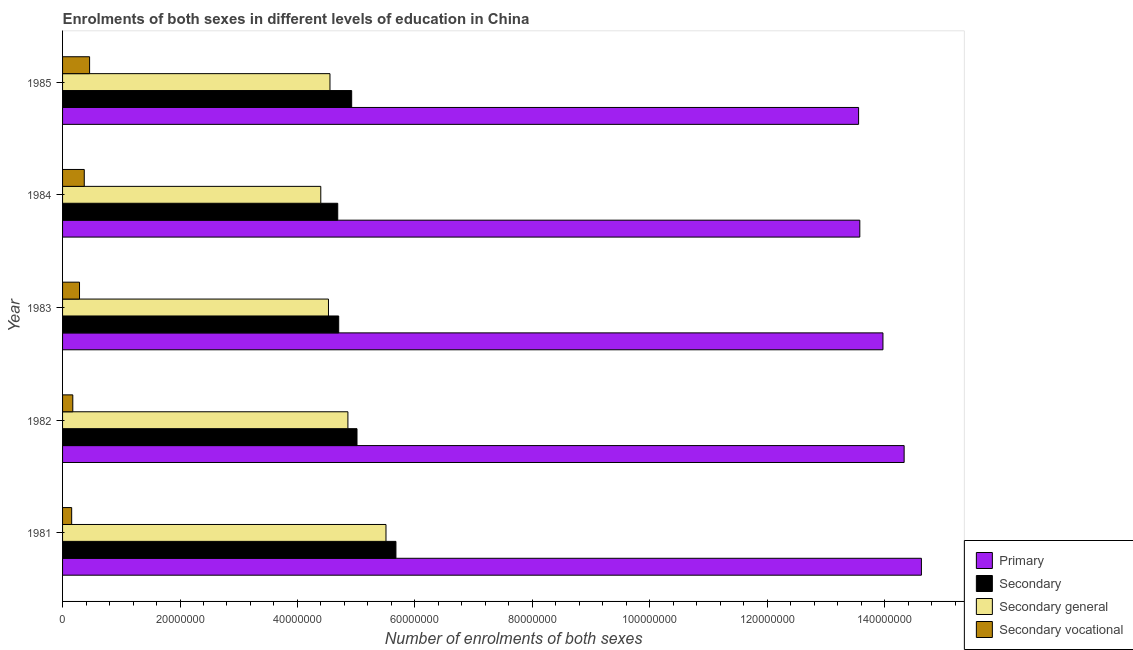Are the number of bars on each tick of the Y-axis equal?
Offer a very short reply. Yes. How many bars are there on the 1st tick from the top?
Your answer should be very brief. 4. How many bars are there on the 5th tick from the bottom?
Your response must be concise. 4. What is the label of the 3rd group of bars from the top?
Your answer should be very brief. 1983. In how many cases, is the number of bars for a given year not equal to the number of legend labels?
Make the answer very short. 0. What is the number of enrolments in secondary vocational education in 1984?
Provide a short and direct response. 3.70e+06. Across all years, what is the maximum number of enrolments in primary education?
Make the answer very short. 1.46e+08. Across all years, what is the minimum number of enrolments in secondary general education?
Make the answer very short. 4.40e+07. What is the total number of enrolments in secondary vocational education in the graph?
Your answer should be compact. 1.45e+07. What is the difference between the number of enrolments in primary education in 1981 and that in 1984?
Offer a very short reply. 1.05e+07. What is the difference between the number of enrolments in secondary general education in 1982 and the number of enrolments in secondary education in 1983?
Offer a terse response. 1.57e+06. What is the average number of enrolments in primary education per year?
Your response must be concise. 1.40e+08. In the year 1981, what is the difference between the number of enrolments in primary education and number of enrolments in secondary education?
Ensure brevity in your answer.  8.95e+07. What is the ratio of the number of enrolments in primary education in 1982 to that in 1985?
Offer a terse response. 1.06. Is the number of enrolments in primary education in 1981 less than that in 1985?
Ensure brevity in your answer.  No. What is the difference between the highest and the second highest number of enrolments in secondary education?
Keep it short and to the point. 6.63e+06. What is the difference between the highest and the lowest number of enrolments in primary education?
Your answer should be compact. 1.07e+07. Is the sum of the number of enrolments in secondary vocational education in 1982 and 1985 greater than the maximum number of enrolments in secondary education across all years?
Your answer should be compact. No. What does the 1st bar from the top in 1981 represents?
Offer a very short reply. Secondary vocational. What does the 3rd bar from the bottom in 1981 represents?
Provide a succinct answer. Secondary general. Is it the case that in every year, the sum of the number of enrolments in primary education and number of enrolments in secondary education is greater than the number of enrolments in secondary general education?
Provide a short and direct response. Yes. How many bars are there?
Give a very brief answer. 20. Are all the bars in the graph horizontal?
Provide a succinct answer. Yes. How many years are there in the graph?
Make the answer very short. 5. What is the difference between two consecutive major ticks on the X-axis?
Your response must be concise. 2.00e+07. Where does the legend appear in the graph?
Give a very brief answer. Bottom right. How many legend labels are there?
Your answer should be compact. 4. What is the title of the graph?
Your response must be concise. Enrolments of both sexes in different levels of education in China. Does "Mammal species" appear as one of the legend labels in the graph?
Your answer should be compact. No. What is the label or title of the X-axis?
Your response must be concise. Number of enrolments of both sexes. What is the Number of enrolments of both sexes of Primary in 1981?
Provide a short and direct response. 1.46e+08. What is the Number of enrolments of both sexes in Secondary in 1981?
Your answer should be very brief. 5.68e+07. What is the Number of enrolments of both sexes in Secondary general in 1981?
Make the answer very short. 5.51e+07. What is the Number of enrolments of both sexes in Secondary vocational in 1981?
Ensure brevity in your answer.  1.55e+06. What is the Number of enrolments of both sexes in Primary in 1982?
Provide a short and direct response. 1.43e+08. What is the Number of enrolments of both sexes in Secondary in 1982?
Offer a very short reply. 5.01e+07. What is the Number of enrolments of both sexes in Secondary general in 1982?
Provide a succinct answer. 4.86e+07. What is the Number of enrolments of both sexes of Secondary vocational in 1982?
Provide a succinct answer. 1.74e+06. What is the Number of enrolments of both sexes of Primary in 1983?
Offer a very short reply. 1.40e+08. What is the Number of enrolments of both sexes of Secondary in 1983?
Offer a very short reply. 4.70e+07. What is the Number of enrolments of both sexes in Secondary general in 1983?
Offer a terse response. 4.53e+07. What is the Number of enrolments of both sexes of Secondary vocational in 1983?
Make the answer very short. 2.89e+06. What is the Number of enrolments of both sexes in Primary in 1984?
Provide a succinct answer. 1.36e+08. What is the Number of enrolments of both sexes of Secondary in 1984?
Provide a short and direct response. 4.69e+07. What is the Number of enrolments of both sexes in Secondary general in 1984?
Give a very brief answer. 4.40e+07. What is the Number of enrolments of both sexes of Secondary vocational in 1984?
Keep it short and to the point. 3.70e+06. What is the Number of enrolments of both sexes in Primary in 1985?
Give a very brief answer. 1.36e+08. What is the Number of enrolments of both sexes of Secondary in 1985?
Ensure brevity in your answer.  4.92e+07. What is the Number of enrolments of both sexes of Secondary general in 1985?
Keep it short and to the point. 4.55e+07. What is the Number of enrolments of both sexes in Secondary vocational in 1985?
Your response must be concise. 4.60e+06. Across all years, what is the maximum Number of enrolments of both sexes in Primary?
Ensure brevity in your answer.  1.46e+08. Across all years, what is the maximum Number of enrolments of both sexes of Secondary?
Offer a terse response. 5.68e+07. Across all years, what is the maximum Number of enrolments of both sexes in Secondary general?
Your answer should be compact. 5.51e+07. Across all years, what is the maximum Number of enrolments of both sexes of Secondary vocational?
Ensure brevity in your answer.  4.60e+06. Across all years, what is the minimum Number of enrolments of both sexes in Primary?
Your answer should be very brief. 1.36e+08. Across all years, what is the minimum Number of enrolments of both sexes of Secondary?
Offer a very short reply. 4.69e+07. Across all years, what is the minimum Number of enrolments of both sexes in Secondary general?
Make the answer very short. 4.40e+07. Across all years, what is the minimum Number of enrolments of both sexes of Secondary vocational?
Provide a short and direct response. 1.55e+06. What is the total Number of enrolments of both sexes in Primary in the graph?
Make the answer very short. 7.01e+08. What is the total Number of enrolments of both sexes in Secondary in the graph?
Offer a very short reply. 2.50e+08. What is the total Number of enrolments of both sexes in Secondary general in the graph?
Make the answer very short. 2.38e+08. What is the total Number of enrolments of both sexes of Secondary vocational in the graph?
Make the answer very short. 1.45e+07. What is the difference between the Number of enrolments of both sexes of Primary in 1981 and that in 1982?
Provide a succinct answer. 2.94e+06. What is the difference between the Number of enrolments of both sexes of Secondary in 1981 and that in 1982?
Keep it short and to the point. 6.63e+06. What is the difference between the Number of enrolments of both sexes in Secondary general in 1981 and that in 1982?
Make the answer very short. 6.48e+06. What is the difference between the Number of enrolments of both sexes of Secondary vocational in 1981 and that in 1982?
Provide a succinct answer. -1.93e+05. What is the difference between the Number of enrolments of both sexes of Primary in 1981 and that in 1983?
Offer a terse response. 6.55e+06. What is the difference between the Number of enrolments of both sexes in Secondary in 1981 and that in 1983?
Offer a very short reply. 9.75e+06. What is the difference between the Number of enrolments of both sexes in Secondary general in 1981 and that in 1983?
Your response must be concise. 9.80e+06. What is the difference between the Number of enrolments of both sexes of Secondary vocational in 1981 and that in 1983?
Your answer should be very brief. -1.34e+06. What is the difference between the Number of enrolments of both sexes of Primary in 1981 and that in 1984?
Offer a terse response. 1.05e+07. What is the difference between the Number of enrolments of both sexes in Secondary in 1981 and that in 1984?
Give a very brief answer. 9.91e+06. What is the difference between the Number of enrolments of both sexes of Secondary general in 1981 and that in 1984?
Your answer should be compact. 1.11e+07. What is the difference between the Number of enrolments of both sexes in Secondary vocational in 1981 and that in 1984?
Your response must be concise. -2.15e+06. What is the difference between the Number of enrolments of both sexes of Primary in 1981 and that in 1985?
Give a very brief answer. 1.07e+07. What is the difference between the Number of enrolments of both sexes of Secondary in 1981 and that in 1985?
Give a very brief answer. 7.54e+06. What is the difference between the Number of enrolments of both sexes of Secondary general in 1981 and that in 1985?
Offer a very short reply. 9.54e+06. What is the difference between the Number of enrolments of both sexes of Secondary vocational in 1981 and that in 1985?
Provide a succinct answer. -3.05e+06. What is the difference between the Number of enrolments of both sexes of Primary in 1982 and that in 1983?
Give a very brief answer. 3.61e+06. What is the difference between the Number of enrolments of both sexes of Secondary in 1982 and that in 1983?
Make the answer very short. 3.12e+06. What is the difference between the Number of enrolments of both sexes of Secondary general in 1982 and that in 1983?
Give a very brief answer. 3.31e+06. What is the difference between the Number of enrolments of both sexes in Secondary vocational in 1982 and that in 1983?
Provide a short and direct response. -1.14e+06. What is the difference between the Number of enrolments of both sexes in Primary in 1982 and that in 1984?
Your answer should be very brief. 7.55e+06. What is the difference between the Number of enrolments of both sexes of Secondary in 1982 and that in 1984?
Give a very brief answer. 3.28e+06. What is the difference between the Number of enrolments of both sexes of Secondary general in 1982 and that in 1984?
Make the answer very short. 4.62e+06. What is the difference between the Number of enrolments of both sexes in Secondary vocational in 1982 and that in 1984?
Keep it short and to the point. -1.95e+06. What is the difference between the Number of enrolments of both sexes in Primary in 1982 and that in 1985?
Offer a very short reply. 7.76e+06. What is the difference between the Number of enrolments of both sexes of Secondary in 1982 and that in 1985?
Make the answer very short. 9.09e+05. What is the difference between the Number of enrolments of both sexes in Secondary general in 1982 and that in 1985?
Offer a very short reply. 3.05e+06. What is the difference between the Number of enrolments of both sexes in Secondary vocational in 1982 and that in 1985?
Offer a terse response. -2.86e+06. What is the difference between the Number of enrolments of both sexes of Primary in 1983 and that in 1984?
Offer a very short reply. 3.94e+06. What is the difference between the Number of enrolments of both sexes in Secondary in 1983 and that in 1984?
Ensure brevity in your answer.  1.63e+05. What is the difference between the Number of enrolments of both sexes in Secondary general in 1983 and that in 1984?
Your response must be concise. 1.31e+06. What is the difference between the Number of enrolments of both sexes in Secondary vocational in 1983 and that in 1984?
Offer a very short reply. -8.08e+05. What is the difference between the Number of enrolments of both sexes of Primary in 1983 and that in 1985?
Your response must be concise. 4.15e+06. What is the difference between the Number of enrolments of both sexes of Secondary in 1983 and that in 1985?
Keep it short and to the point. -2.21e+06. What is the difference between the Number of enrolments of both sexes in Secondary general in 1983 and that in 1985?
Make the answer very short. -2.56e+05. What is the difference between the Number of enrolments of both sexes in Secondary vocational in 1983 and that in 1985?
Make the answer very short. -1.72e+06. What is the difference between the Number of enrolments of both sexes in Primary in 1984 and that in 1985?
Provide a short and direct response. 2.09e+05. What is the difference between the Number of enrolments of both sexes in Secondary in 1984 and that in 1985?
Keep it short and to the point. -2.37e+06. What is the difference between the Number of enrolments of both sexes of Secondary general in 1984 and that in 1985?
Offer a terse response. -1.56e+06. What is the difference between the Number of enrolments of both sexes in Secondary vocational in 1984 and that in 1985?
Provide a succinct answer. -9.09e+05. What is the difference between the Number of enrolments of both sexes in Primary in 1981 and the Number of enrolments of both sexes in Secondary in 1982?
Offer a very short reply. 9.61e+07. What is the difference between the Number of enrolments of both sexes in Primary in 1981 and the Number of enrolments of both sexes in Secondary general in 1982?
Your answer should be very brief. 9.77e+07. What is the difference between the Number of enrolments of both sexes in Primary in 1981 and the Number of enrolments of both sexes in Secondary vocational in 1982?
Your answer should be very brief. 1.45e+08. What is the difference between the Number of enrolments of both sexes of Secondary in 1981 and the Number of enrolments of both sexes of Secondary general in 1982?
Give a very brief answer. 8.18e+06. What is the difference between the Number of enrolments of both sexes of Secondary in 1981 and the Number of enrolments of both sexes of Secondary vocational in 1982?
Keep it short and to the point. 5.50e+07. What is the difference between the Number of enrolments of both sexes in Secondary general in 1981 and the Number of enrolments of both sexes in Secondary vocational in 1982?
Your answer should be compact. 5.33e+07. What is the difference between the Number of enrolments of both sexes of Primary in 1981 and the Number of enrolments of both sexes of Secondary in 1983?
Offer a very short reply. 9.92e+07. What is the difference between the Number of enrolments of both sexes of Primary in 1981 and the Number of enrolments of both sexes of Secondary general in 1983?
Your answer should be very brief. 1.01e+08. What is the difference between the Number of enrolments of both sexes in Primary in 1981 and the Number of enrolments of both sexes in Secondary vocational in 1983?
Make the answer very short. 1.43e+08. What is the difference between the Number of enrolments of both sexes of Secondary in 1981 and the Number of enrolments of both sexes of Secondary general in 1983?
Provide a short and direct response. 1.15e+07. What is the difference between the Number of enrolments of both sexes of Secondary in 1981 and the Number of enrolments of both sexes of Secondary vocational in 1983?
Make the answer very short. 5.39e+07. What is the difference between the Number of enrolments of both sexes in Secondary general in 1981 and the Number of enrolments of both sexes in Secondary vocational in 1983?
Your answer should be compact. 5.22e+07. What is the difference between the Number of enrolments of both sexes in Primary in 1981 and the Number of enrolments of both sexes in Secondary in 1984?
Provide a succinct answer. 9.94e+07. What is the difference between the Number of enrolments of both sexes in Primary in 1981 and the Number of enrolments of both sexes in Secondary general in 1984?
Ensure brevity in your answer.  1.02e+08. What is the difference between the Number of enrolments of both sexes of Primary in 1981 and the Number of enrolments of both sexes of Secondary vocational in 1984?
Your answer should be compact. 1.43e+08. What is the difference between the Number of enrolments of both sexes in Secondary in 1981 and the Number of enrolments of both sexes in Secondary general in 1984?
Your answer should be compact. 1.28e+07. What is the difference between the Number of enrolments of both sexes of Secondary in 1981 and the Number of enrolments of both sexes of Secondary vocational in 1984?
Keep it short and to the point. 5.31e+07. What is the difference between the Number of enrolments of both sexes in Secondary general in 1981 and the Number of enrolments of both sexes in Secondary vocational in 1984?
Offer a very short reply. 5.14e+07. What is the difference between the Number of enrolments of both sexes in Primary in 1981 and the Number of enrolments of both sexes in Secondary in 1985?
Offer a very short reply. 9.70e+07. What is the difference between the Number of enrolments of both sexes of Primary in 1981 and the Number of enrolments of both sexes of Secondary general in 1985?
Keep it short and to the point. 1.01e+08. What is the difference between the Number of enrolments of both sexes of Primary in 1981 and the Number of enrolments of both sexes of Secondary vocational in 1985?
Keep it short and to the point. 1.42e+08. What is the difference between the Number of enrolments of both sexes of Secondary in 1981 and the Number of enrolments of both sexes of Secondary general in 1985?
Keep it short and to the point. 1.12e+07. What is the difference between the Number of enrolments of both sexes in Secondary in 1981 and the Number of enrolments of both sexes in Secondary vocational in 1985?
Provide a short and direct response. 5.22e+07. What is the difference between the Number of enrolments of both sexes of Secondary general in 1981 and the Number of enrolments of both sexes of Secondary vocational in 1985?
Offer a terse response. 5.05e+07. What is the difference between the Number of enrolments of both sexes of Primary in 1982 and the Number of enrolments of both sexes of Secondary in 1983?
Provide a succinct answer. 9.63e+07. What is the difference between the Number of enrolments of both sexes in Primary in 1982 and the Number of enrolments of both sexes in Secondary general in 1983?
Your response must be concise. 9.80e+07. What is the difference between the Number of enrolments of both sexes in Primary in 1982 and the Number of enrolments of both sexes in Secondary vocational in 1983?
Make the answer very short. 1.40e+08. What is the difference between the Number of enrolments of both sexes of Secondary in 1982 and the Number of enrolments of both sexes of Secondary general in 1983?
Offer a terse response. 4.86e+06. What is the difference between the Number of enrolments of both sexes of Secondary in 1982 and the Number of enrolments of both sexes of Secondary vocational in 1983?
Your response must be concise. 4.73e+07. What is the difference between the Number of enrolments of both sexes of Secondary general in 1982 and the Number of enrolments of both sexes of Secondary vocational in 1983?
Offer a terse response. 4.57e+07. What is the difference between the Number of enrolments of both sexes in Primary in 1982 and the Number of enrolments of both sexes in Secondary in 1984?
Provide a short and direct response. 9.65e+07. What is the difference between the Number of enrolments of both sexes of Primary in 1982 and the Number of enrolments of both sexes of Secondary general in 1984?
Give a very brief answer. 9.94e+07. What is the difference between the Number of enrolments of both sexes of Primary in 1982 and the Number of enrolments of both sexes of Secondary vocational in 1984?
Keep it short and to the point. 1.40e+08. What is the difference between the Number of enrolments of both sexes of Secondary in 1982 and the Number of enrolments of both sexes of Secondary general in 1984?
Offer a terse response. 6.17e+06. What is the difference between the Number of enrolments of both sexes in Secondary in 1982 and the Number of enrolments of both sexes in Secondary vocational in 1984?
Offer a very short reply. 4.65e+07. What is the difference between the Number of enrolments of both sexes of Secondary general in 1982 and the Number of enrolments of both sexes of Secondary vocational in 1984?
Your response must be concise. 4.49e+07. What is the difference between the Number of enrolments of both sexes of Primary in 1982 and the Number of enrolments of both sexes of Secondary in 1985?
Your answer should be compact. 9.41e+07. What is the difference between the Number of enrolments of both sexes in Primary in 1982 and the Number of enrolments of both sexes in Secondary general in 1985?
Your answer should be very brief. 9.78e+07. What is the difference between the Number of enrolments of both sexes of Primary in 1982 and the Number of enrolments of both sexes of Secondary vocational in 1985?
Your answer should be very brief. 1.39e+08. What is the difference between the Number of enrolments of both sexes in Secondary in 1982 and the Number of enrolments of both sexes in Secondary general in 1985?
Your response must be concise. 4.60e+06. What is the difference between the Number of enrolments of both sexes in Secondary in 1982 and the Number of enrolments of both sexes in Secondary vocational in 1985?
Give a very brief answer. 4.55e+07. What is the difference between the Number of enrolments of both sexes in Secondary general in 1982 and the Number of enrolments of both sexes in Secondary vocational in 1985?
Make the answer very short. 4.40e+07. What is the difference between the Number of enrolments of both sexes of Primary in 1983 and the Number of enrolments of both sexes of Secondary in 1984?
Your response must be concise. 9.29e+07. What is the difference between the Number of enrolments of both sexes in Primary in 1983 and the Number of enrolments of both sexes in Secondary general in 1984?
Ensure brevity in your answer.  9.57e+07. What is the difference between the Number of enrolments of both sexes in Primary in 1983 and the Number of enrolments of both sexes in Secondary vocational in 1984?
Your answer should be very brief. 1.36e+08. What is the difference between the Number of enrolments of both sexes in Secondary in 1983 and the Number of enrolments of both sexes in Secondary general in 1984?
Offer a very short reply. 3.05e+06. What is the difference between the Number of enrolments of both sexes of Secondary in 1983 and the Number of enrolments of both sexes of Secondary vocational in 1984?
Offer a very short reply. 4.33e+07. What is the difference between the Number of enrolments of both sexes in Secondary general in 1983 and the Number of enrolments of both sexes in Secondary vocational in 1984?
Provide a succinct answer. 4.16e+07. What is the difference between the Number of enrolments of both sexes of Primary in 1983 and the Number of enrolments of both sexes of Secondary in 1985?
Ensure brevity in your answer.  9.05e+07. What is the difference between the Number of enrolments of both sexes in Primary in 1983 and the Number of enrolments of both sexes in Secondary general in 1985?
Offer a terse response. 9.42e+07. What is the difference between the Number of enrolments of both sexes in Primary in 1983 and the Number of enrolments of both sexes in Secondary vocational in 1985?
Provide a short and direct response. 1.35e+08. What is the difference between the Number of enrolments of both sexes of Secondary in 1983 and the Number of enrolments of both sexes of Secondary general in 1985?
Your response must be concise. 1.49e+06. What is the difference between the Number of enrolments of both sexes of Secondary in 1983 and the Number of enrolments of both sexes of Secondary vocational in 1985?
Provide a succinct answer. 4.24e+07. What is the difference between the Number of enrolments of both sexes in Secondary general in 1983 and the Number of enrolments of both sexes in Secondary vocational in 1985?
Keep it short and to the point. 4.07e+07. What is the difference between the Number of enrolments of both sexes in Primary in 1984 and the Number of enrolments of both sexes in Secondary in 1985?
Provide a succinct answer. 8.65e+07. What is the difference between the Number of enrolments of both sexes in Primary in 1984 and the Number of enrolments of both sexes in Secondary general in 1985?
Make the answer very short. 9.02e+07. What is the difference between the Number of enrolments of both sexes of Primary in 1984 and the Number of enrolments of both sexes of Secondary vocational in 1985?
Your answer should be very brief. 1.31e+08. What is the difference between the Number of enrolments of both sexes in Secondary in 1984 and the Number of enrolments of both sexes in Secondary general in 1985?
Ensure brevity in your answer.  1.32e+06. What is the difference between the Number of enrolments of both sexes in Secondary in 1984 and the Number of enrolments of both sexes in Secondary vocational in 1985?
Provide a succinct answer. 4.23e+07. What is the difference between the Number of enrolments of both sexes in Secondary general in 1984 and the Number of enrolments of both sexes in Secondary vocational in 1985?
Offer a very short reply. 3.94e+07. What is the average Number of enrolments of both sexes in Primary per year?
Offer a terse response. 1.40e+08. What is the average Number of enrolments of both sexes in Secondary per year?
Your answer should be compact. 5.00e+07. What is the average Number of enrolments of both sexes of Secondary general per year?
Keep it short and to the point. 4.77e+07. What is the average Number of enrolments of both sexes in Secondary vocational per year?
Your answer should be compact. 2.90e+06. In the year 1981, what is the difference between the Number of enrolments of both sexes of Primary and Number of enrolments of both sexes of Secondary?
Your answer should be very brief. 8.95e+07. In the year 1981, what is the difference between the Number of enrolments of both sexes of Primary and Number of enrolments of both sexes of Secondary general?
Your answer should be compact. 9.12e+07. In the year 1981, what is the difference between the Number of enrolments of both sexes in Primary and Number of enrolments of both sexes in Secondary vocational?
Your answer should be very brief. 1.45e+08. In the year 1981, what is the difference between the Number of enrolments of both sexes in Secondary and Number of enrolments of both sexes in Secondary general?
Keep it short and to the point. 1.70e+06. In the year 1981, what is the difference between the Number of enrolments of both sexes of Secondary and Number of enrolments of both sexes of Secondary vocational?
Offer a very short reply. 5.52e+07. In the year 1981, what is the difference between the Number of enrolments of both sexes in Secondary general and Number of enrolments of both sexes in Secondary vocational?
Keep it short and to the point. 5.35e+07. In the year 1982, what is the difference between the Number of enrolments of both sexes in Primary and Number of enrolments of both sexes in Secondary?
Your answer should be compact. 9.32e+07. In the year 1982, what is the difference between the Number of enrolments of both sexes of Primary and Number of enrolments of both sexes of Secondary general?
Offer a terse response. 9.47e+07. In the year 1982, what is the difference between the Number of enrolments of both sexes of Primary and Number of enrolments of both sexes of Secondary vocational?
Provide a short and direct response. 1.42e+08. In the year 1982, what is the difference between the Number of enrolments of both sexes in Secondary and Number of enrolments of both sexes in Secondary general?
Offer a very short reply. 1.55e+06. In the year 1982, what is the difference between the Number of enrolments of both sexes in Secondary and Number of enrolments of both sexes in Secondary vocational?
Make the answer very short. 4.84e+07. In the year 1982, what is the difference between the Number of enrolments of both sexes of Secondary general and Number of enrolments of both sexes of Secondary vocational?
Ensure brevity in your answer.  4.69e+07. In the year 1983, what is the difference between the Number of enrolments of both sexes of Primary and Number of enrolments of both sexes of Secondary?
Your answer should be compact. 9.27e+07. In the year 1983, what is the difference between the Number of enrolments of both sexes in Primary and Number of enrolments of both sexes in Secondary general?
Your answer should be very brief. 9.44e+07. In the year 1983, what is the difference between the Number of enrolments of both sexes of Primary and Number of enrolments of both sexes of Secondary vocational?
Your response must be concise. 1.37e+08. In the year 1983, what is the difference between the Number of enrolments of both sexes in Secondary and Number of enrolments of both sexes in Secondary general?
Provide a short and direct response. 1.74e+06. In the year 1983, what is the difference between the Number of enrolments of both sexes in Secondary and Number of enrolments of both sexes in Secondary vocational?
Provide a short and direct response. 4.41e+07. In the year 1983, what is the difference between the Number of enrolments of both sexes of Secondary general and Number of enrolments of both sexes of Secondary vocational?
Ensure brevity in your answer.  4.24e+07. In the year 1984, what is the difference between the Number of enrolments of both sexes of Primary and Number of enrolments of both sexes of Secondary?
Provide a succinct answer. 8.89e+07. In the year 1984, what is the difference between the Number of enrolments of both sexes in Primary and Number of enrolments of both sexes in Secondary general?
Your answer should be compact. 9.18e+07. In the year 1984, what is the difference between the Number of enrolments of both sexes of Primary and Number of enrolments of both sexes of Secondary vocational?
Your response must be concise. 1.32e+08. In the year 1984, what is the difference between the Number of enrolments of both sexes of Secondary and Number of enrolments of both sexes of Secondary general?
Your answer should be very brief. 2.89e+06. In the year 1984, what is the difference between the Number of enrolments of both sexes of Secondary and Number of enrolments of both sexes of Secondary vocational?
Provide a succinct answer. 4.32e+07. In the year 1984, what is the difference between the Number of enrolments of both sexes of Secondary general and Number of enrolments of both sexes of Secondary vocational?
Offer a very short reply. 4.03e+07. In the year 1985, what is the difference between the Number of enrolments of both sexes of Primary and Number of enrolments of both sexes of Secondary?
Offer a terse response. 8.63e+07. In the year 1985, what is the difference between the Number of enrolments of both sexes of Primary and Number of enrolments of both sexes of Secondary general?
Provide a short and direct response. 9.00e+07. In the year 1985, what is the difference between the Number of enrolments of both sexes of Primary and Number of enrolments of both sexes of Secondary vocational?
Offer a very short reply. 1.31e+08. In the year 1985, what is the difference between the Number of enrolments of both sexes in Secondary and Number of enrolments of both sexes in Secondary general?
Your answer should be very brief. 3.70e+06. In the year 1985, what is the difference between the Number of enrolments of both sexes in Secondary and Number of enrolments of both sexes in Secondary vocational?
Offer a terse response. 4.46e+07. In the year 1985, what is the difference between the Number of enrolments of both sexes of Secondary general and Number of enrolments of both sexes of Secondary vocational?
Your response must be concise. 4.09e+07. What is the ratio of the Number of enrolments of both sexes in Primary in 1981 to that in 1982?
Your response must be concise. 1.02. What is the ratio of the Number of enrolments of both sexes of Secondary in 1981 to that in 1982?
Make the answer very short. 1.13. What is the ratio of the Number of enrolments of both sexes in Secondary general in 1981 to that in 1982?
Provide a short and direct response. 1.13. What is the ratio of the Number of enrolments of both sexes of Secondary vocational in 1981 to that in 1982?
Offer a terse response. 0.89. What is the ratio of the Number of enrolments of both sexes of Primary in 1981 to that in 1983?
Offer a terse response. 1.05. What is the ratio of the Number of enrolments of both sexes in Secondary in 1981 to that in 1983?
Ensure brevity in your answer.  1.21. What is the ratio of the Number of enrolments of both sexes of Secondary general in 1981 to that in 1983?
Provide a short and direct response. 1.22. What is the ratio of the Number of enrolments of both sexes of Secondary vocational in 1981 to that in 1983?
Keep it short and to the point. 0.54. What is the ratio of the Number of enrolments of both sexes in Primary in 1981 to that in 1984?
Keep it short and to the point. 1.08. What is the ratio of the Number of enrolments of both sexes of Secondary in 1981 to that in 1984?
Give a very brief answer. 1.21. What is the ratio of the Number of enrolments of both sexes of Secondary general in 1981 to that in 1984?
Keep it short and to the point. 1.25. What is the ratio of the Number of enrolments of both sexes in Secondary vocational in 1981 to that in 1984?
Your answer should be compact. 0.42. What is the ratio of the Number of enrolments of both sexes in Primary in 1981 to that in 1985?
Keep it short and to the point. 1.08. What is the ratio of the Number of enrolments of both sexes in Secondary in 1981 to that in 1985?
Give a very brief answer. 1.15. What is the ratio of the Number of enrolments of both sexes of Secondary general in 1981 to that in 1985?
Give a very brief answer. 1.21. What is the ratio of the Number of enrolments of both sexes in Secondary vocational in 1981 to that in 1985?
Provide a short and direct response. 0.34. What is the ratio of the Number of enrolments of both sexes of Primary in 1982 to that in 1983?
Your answer should be very brief. 1.03. What is the ratio of the Number of enrolments of both sexes in Secondary in 1982 to that in 1983?
Give a very brief answer. 1.07. What is the ratio of the Number of enrolments of both sexes of Secondary general in 1982 to that in 1983?
Your answer should be very brief. 1.07. What is the ratio of the Number of enrolments of both sexes in Secondary vocational in 1982 to that in 1983?
Make the answer very short. 0.6. What is the ratio of the Number of enrolments of both sexes in Primary in 1982 to that in 1984?
Your answer should be very brief. 1.06. What is the ratio of the Number of enrolments of both sexes in Secondary in 1982 to that in 1984?
Make the answer very short. 1.07. What is the ratio of the Number of enrolments of both sexes of Secondary general in 1982 to that in 1984?
Your answer should be very brief. 1.1. What is the ratio of the Number of enrolments of both sexes in Secondary vocational in 1982 to that in 1984?
Provide a short and direct response. 0.47. What is the ratio of the Number of enrolments of both sexes in Primary in 1982 to that in 1985?
Your answer should be very brief. 1.06. What is the ratio of the Number of enrolments of both sexes in Secondary in 1982 to that in 1985?
Provide a short and direct response. 1.02. What is the ratio of the Number of enrolments of both sexes in Secondary general in 1982 to that in 1985?
Make the answer very short. 1.07. What is the ratio of the Number of enrolments of both sexes of Secondary vocational in 1982 to that in 1985?
Provide a short and direct response. 0.38. What is the ratio of the Number of enrolments of both sexes in Primary in 1983 to that in 1984?
Offer a very short reply. 1.03. What is the ratio of the Number of enrolments of both sexes in Secondary in 1983 to that in 1984?
Give a very brief answer. 1. What is the ratio of the Number of enrolments of both sexes of Secondary general in 1983 to that in 1984?
Provide a short and direct response. 1.03. What is the ratio of the Number of enrolments of both sexes in Secondary vocational in 1983 to that in 1984?
Offer a terse response. 0.78. What is the ratio of the Number of enrolments of both sexes of Primary in 1983 to that in 1985?
Your response must be concise. 1.03. What is the ratio of the Number of enrolments of both sexes of Secondary in 1983 to that in 1985?
Ensure brevity in your answer.  0.96. What is the ratio of the Number of enrolments of both sexes of Secondary general in 1983 to that in 1985?
Your response must be concise. 0.99. What is the ratio of the Number of enrolments of both sexes of Secondary vocational in 1983 to that in 1985?
Ensure brevity in your answer.  0.63. What is the ratio of the Number of enrolments of both sexes of Primary in 1984 to that in 1985?
Your response must be concise. 1. What is the ratio of the Number of enrolments of both sexes of Secondary in 1984 to that in 1985?
Provide a succinct answer. 0.95. What is the ratio of the Number of enrolments of both sexes in Secondary general in 1984 to that in 1985?
Ensure brevity in your answer.  0.97. What is the ratio of the Number of enrolments of both sexes of Secondary vocational in 1984 to that in 1985?
Offer a very short reply. 0.8. What is the difference between the highest and the second highest Number of enrolments of both sexes in Primary?
Provide a short and direct response. 2.94e+06. What is the difference between the highest and the second highest Number of enrolments of both sexes of Secondary?
Provide a short and direct response. 6.63e+06. What is the difference between the highest and the second highest Number of enrolments of both sexes in Secondary general?
Offer a very short reply. 6.48e+06. What is the difference between the highest and the second highest Number of enrolments of both sexes in Secondary vocational?
Your response must be concise. 9.09e+05. What is the difference between the highest and the lowest Number of enrolments of both sexes in Primary?
Ensure brevity in your answer.  1.07e+07. What is the difference between the highest and the lowest Number of enrolments of both sexes of Secondary?
Ensure brevity in your answer.  9.91e+06. What is the difference between the highest and the lowest Number of enrolments of both sexes in Secondary general?
Provide a succinct answer. 1.11e+07. What is the difference between the highest and the lowest Number of enrolments of both sexes in Secondary vocational?
Give a very brief answer. 3.05e+06. 